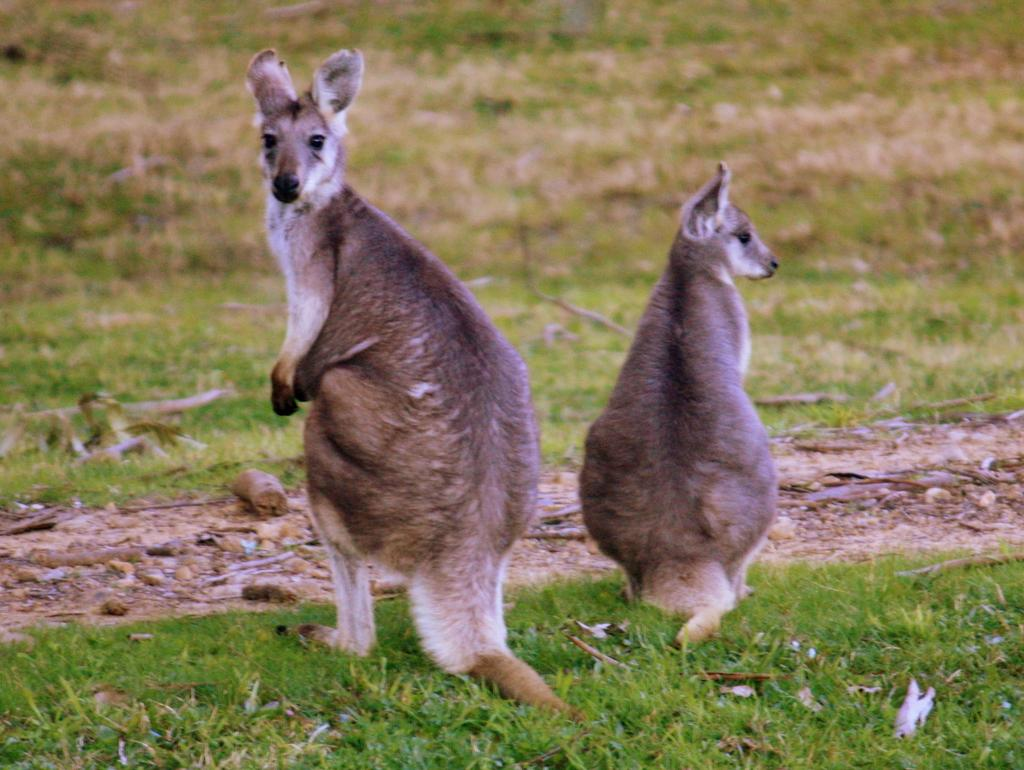What animals are in the foreground of the image? There are two kangaroos in the foreground of the image. What is the surface on which the kangaroos are standing? The kangaroos are on the grass. What type of environment can be seen in the background of the image? There is a grassland in the background of the image. Reasoning: Let' Let's think step by step in order to produce the conversation. We start by identifying the main subjects in the image, which are the two kangaroos. Then, we describe their location and the surface they are standing on, which is the grass. Finally, we expand the conversation to include the background of the image, which is a grassland. Each question is designed to elicit a specific detail about the image that is known from the provided facts. Absurd Question/Answer: Where is the sink located in the image? There is no sink present in the image; it features two kangaroos on the grass with a grassland background. 